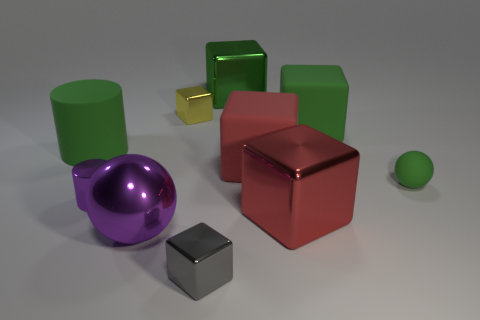There is a object that is behind the small metal cylinder and in front of the red matte thing; how big is it?
Provide a succinct answer. Small. There is a red matte object that is the same size as the purple metal ball; what shape is it?
Make the answer very short. Cube. What material is the big green thing in front of the large green matte thing that is to the right of the small cylinder to the left of the tiny yellow block?
Make the answer very short. Rubber. There is a shiny object that is behind the tiny yellow shiny block; is it the same shape as the green rubber object in front of the matte cylinder?
Provide a succinct answer. No. What number of other objects are there of the same material as the yellow thing?
Your answer should be very brief. 5. Do the ball right of the large purple sphere and the small thing that is in front of the small purple cylinder have the same material?
Offer a terse response. No. What is the shape of the big red object that is the same material as the green ball?
Ensure brevity in your answer.  Cube. Is there anything else that has the same color as the large metal ball?
Give a very brief answer. Yes. What number of small cyan things are there?
Keep it short and to the point. 0. There is a metallic object that is behind the large green matte cylinder and to the right of the yellow thing; what shape is it?
Provide a short and direct response. Cube. 